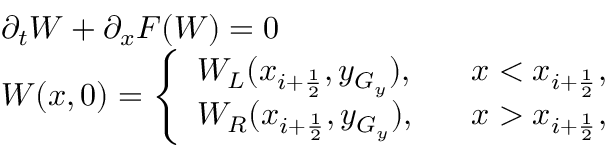<formula> <loc_0><loc_0><loc_500><loc_500>\begin{array} { l l } { \partial _ { t } W + \partial _ { x } F ( W ) = 0 } \\ { W ( x , 0 ) = \left \{ \begin{array} { l l } { W _ { L } ( x _ { i + \frac { 1 } { 2 } } , y _ { G _ { y } } ) , } & { \, x < x _ { i + \frac { 1 } { 2 } } , } \\ { W _ { R } ( x _ { i + \frac { 1 } { 2 } } , y _ { G _ { y } } ) , } & { \, x > x _ { i + \frac { 1 } { 2 } } , } \end{array} } \end{array}</formula> 